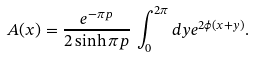<formula> <loc_0><loc_0><loc_500><loc_500>A ( x ) = \frac { e ^ { - \pi p } } { 2 \sinh \pi p } \, \int _ { 0 } ^ { 2 \pi } d y e ^ { 2 \phi ( x + y ) } .</formula> 